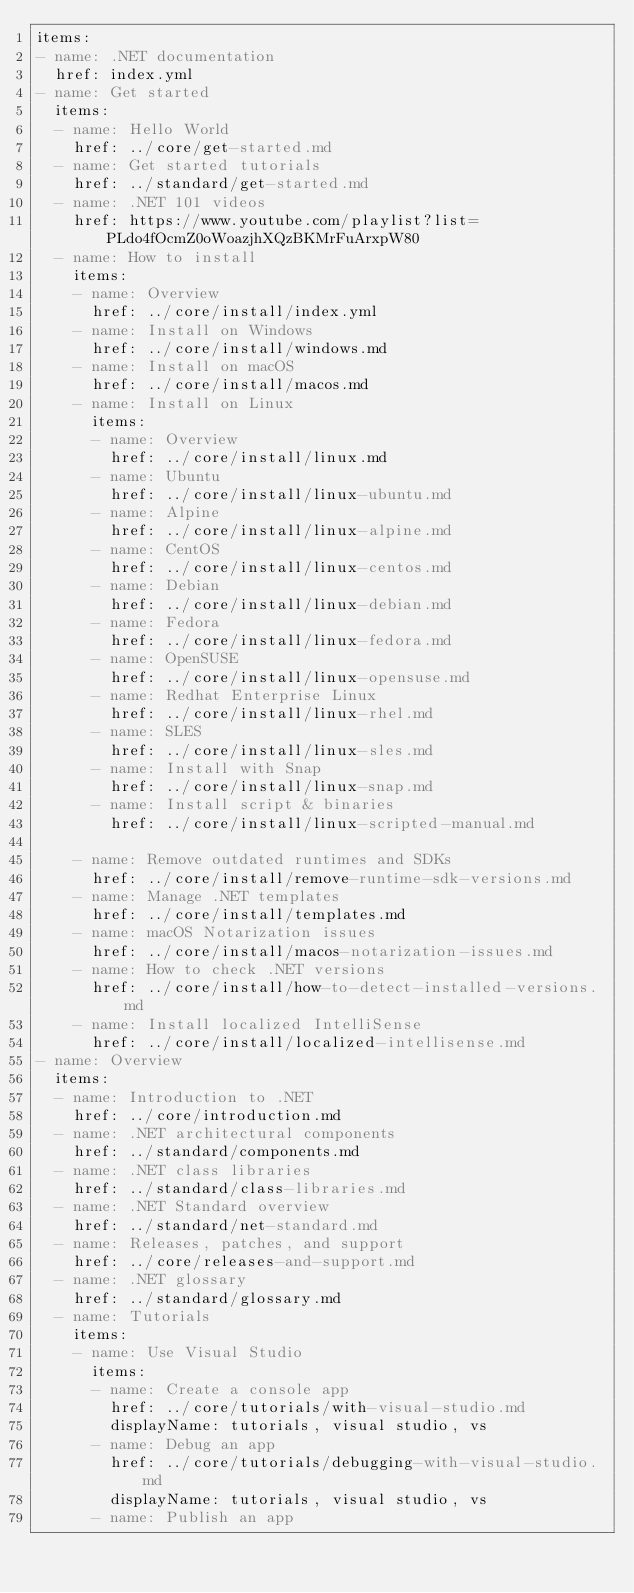Convert code to text. <code><loc_0><loc_0><loc_500><loc_500><_YAML_>items:
- name: .NET documentation
  href: index.yml
- name: Get started
  items:
  - name: Hello World
    href: ../core/get-started.md
  - name: Get started tutorials
    href: ../standard/get-started.md
  - name: .NET 101 videos
    href: https://www.youtube.com/playlist?list=PLdo4fOcmZ0oWoazjhXQzBKMrFuArxpW80
  - name: How to install
    items:
    - name: Overview
      href: ../core/install/index.yml
    - name: Install on Windows
      href: ../core/install/windows.md
    - name: Install on macOS
      href: ../core/install/macos.md
    - name: Install on Linux
      items:
      - name: Overview
        href: ../core/install/linux.md
      - name: Ubuntu
        href: ../core/install/linux-ubuntu.md
      - name: Alpine
        href: ../core/install/linux-alpine.md
      - name: CentOS
        href: ../core/install/linux-centos.md
      - name: Debian
        href: ../core/install/linux-debian.md
      - name: Fedora
        href: ../core/install/linux-fedora.md
      - name: OpenSUSE
        href: ../core/install/linux-opensuse.md
      - name: Redhat Enterprise Linux
        href: ../core/install/linux-rhel.md
      - name: SLES
        href: ../core/install/linux-sles.md
      - name: Install with Snap
        href: ../core/install/linux-snap.md
      - name: Install script & binaries
        href: ../core/install/linux-scripted-manual.md

    - name: Remove outdated runtimes and SDKs
      href: ../core/install/remove-runtime-sdk-versions.md
    - name: Manage .NET templates
      href: ../core/install/templates.md
    - name: macOS Notarization issues
      href: ../core/install/macos-notarization-issues.md
    - name: How to check .NET versions
      href: ../core/install/how-to-detect-installed-versions.md
    - name: Install localized IntelliSense
      href: ../core/install/localized-intellisense.md
- name: Overview
  items:
  - name: Introduction to .NET
    href: ../core/introduction.md
  - name: .NET architectural components
    href: ../standard/components.md
  - name: .NET class libraries
    href: ../standard/class-libraries.md
  - name: .NET Standard overview
    href: ../standard/net-standard.md
  - name: Releases, patches, and support
    href: ../core/releases-and-support.md
  - name: .NET glossary
    href: ../standard/glossary.md
  - name: Tutorials
    items:
    - name: Use Visual Studio
      items:
      - name: Create a console app
        href: ../core/tutorials/with-visual-studio.md
        displayName: tutorials, visual studio, vs
      - name: Debug an app
        href: ../core/tutorials/debugging-with-visual-studio.md
        displayName: tutorials, visual studio, vs
      - name: Publish an app</code> 